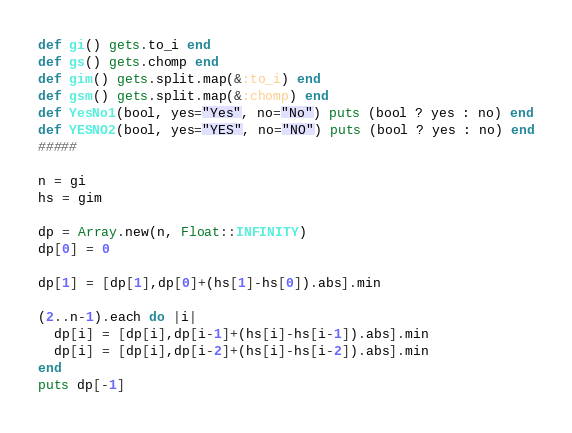<code> <loc_0><loc_0><loc_500><loc_500><_Ruby_>def gi() gets.to_i end
def gs() gets.chomp end
def gim() gets.split.map(&:to_i) end
def gsm() gets.split.map(&:chomp) end
def YesNo1(bool, yes="Yes", no="No") puts (bool ? yes : no) end
def YESNO2(bool, yes="YES", no="NO") puts (bool ? yes : no) end
#####

n = gi
hs = gim

dp = Array.new(n, Float::INFINITY)
dp[0] = 0

dp[1] = [dp[1],dp[0]+(hs[1]-hs[0]).abs].min

(2..n-1).each do |i|
  dp[i] = [dp[i],dp[i-1]+(hs[i]-hs[i-1]).abs].min
  dp[i] = [dp[i],dp[i-2]+(hs[i]-hs[i-2]).abs].min
end
puts dp[-1]</code> 